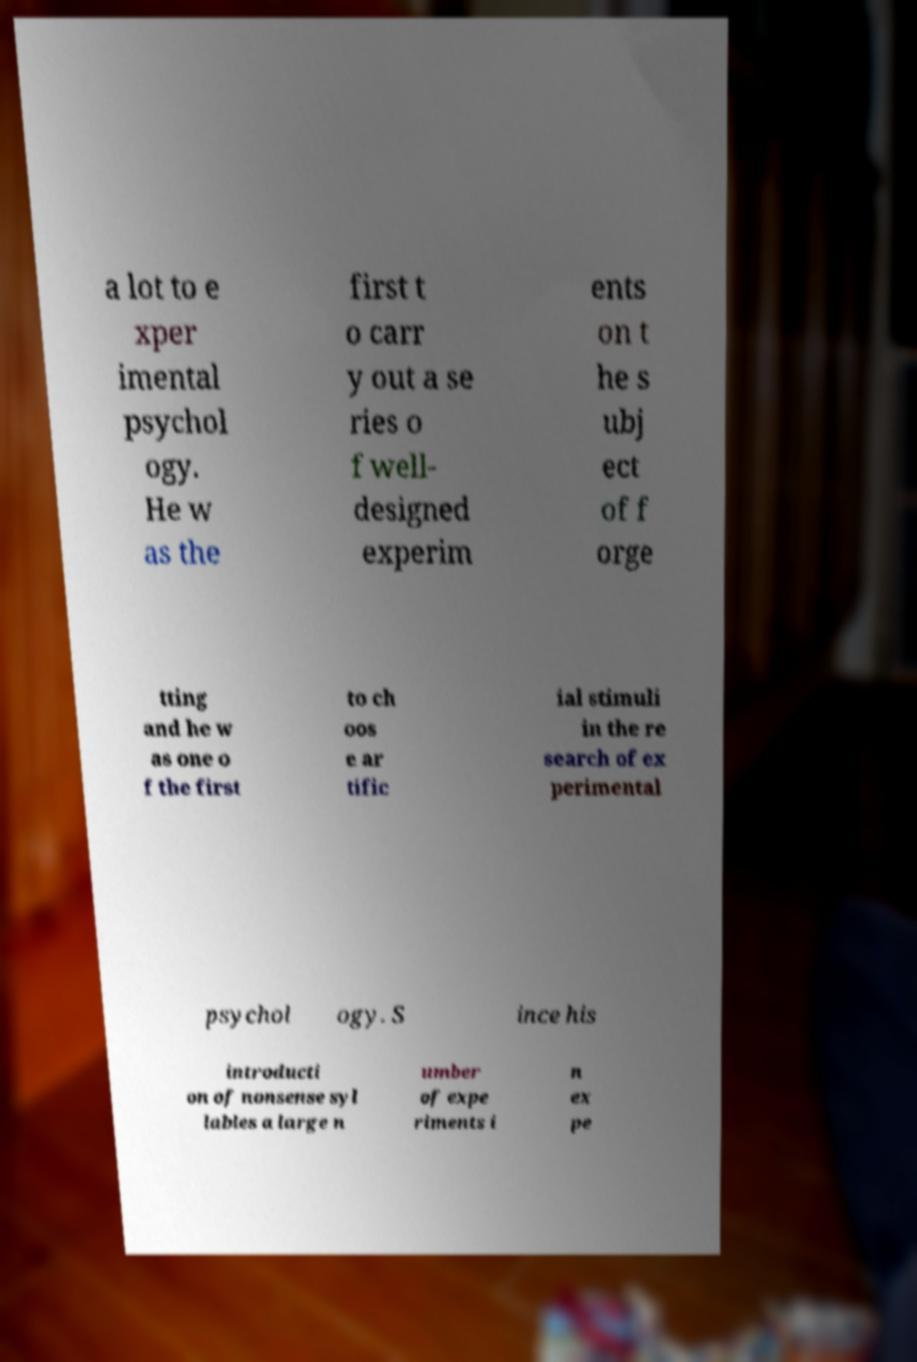For documentation purposes, I need the text within this image transcribed. Could you provide that? a lot to e xper imental psychol ogy. He w as the first t o carr y out a se ries o f well- designed experim ents on t he s ubj ect of f orge tting and he w as one o f the first to ch oos e ar tific ial stimuli in the re search of ex perimental psychol ogy. S ince his introducti on of nonsense syl lables a large n umber of expe riments i n ex pe 